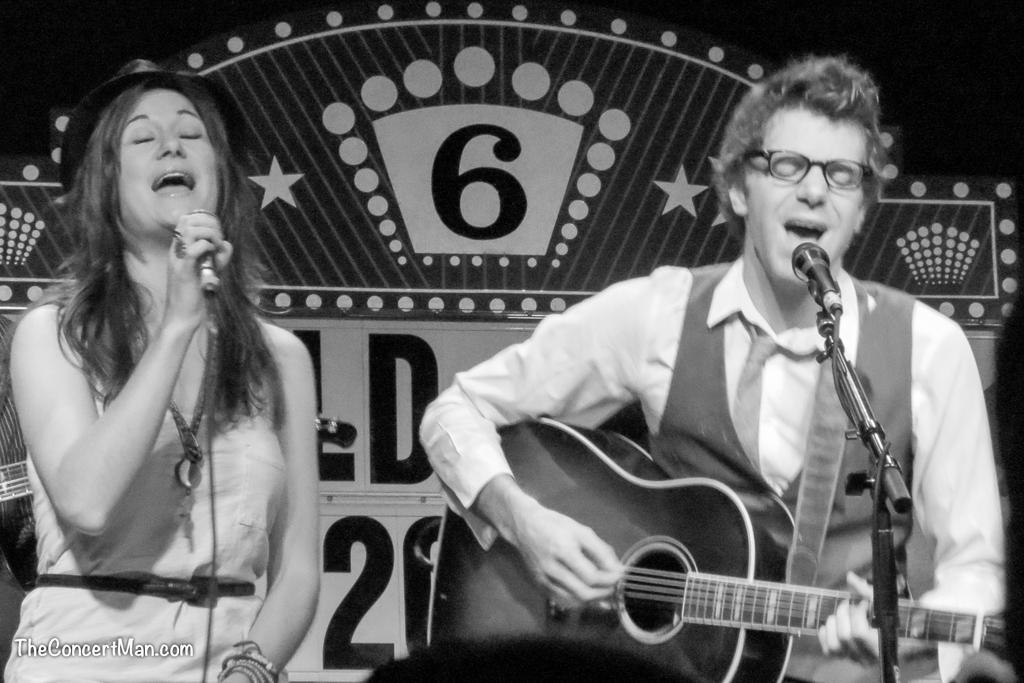What is the woman in the image holding? The woman is holding a microphone. What is the man in the image holding? The man is holding a guitar. How are the man and woman positioned in relation to each other? The man is positioned in front of the picture, while the woman is likely standing beside him. What type of dinner is being served in the image? There is no dinner present in the image; it features a woman holding a microphone and a man holding a guitar. What is the man's thumb doing in the image? There is no mention of the man's thumb in the provided facts, and therefore it cannot be determined what it is doing in the image. 